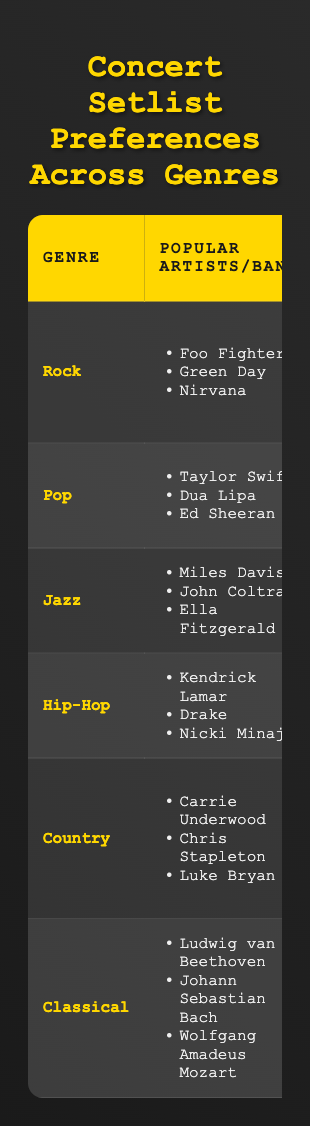What is the average song length for the Pop genre? The table shows that the average song length for the Pop genre is listed as 3:30.
Answer: 3:30 Which genre has the highest audience engagement level? According to the table, both Rock and Hip-Hop have the highest audience engagement level, categorized as "High."
Answer: Rock and Hip-Hop What are the notable instruments used in the Country genre? The table lists "Acoustic Guitar," "Banjo," and "Pedal Steel" as the notable instruments in the Country genre.
Answer: Acoustic Guitar, Banjo, Pedal Steel Which genre features the longest average song length? The average song length for Classical is 7:30, which is longer than Rock (4:15), Pop (3:30), Hip-Hop (3:45), Country (4:20), and Jazz (6:00). Thus, Classical has the longest average song length.
Answer: Classical Is "Symphony No. 5" a popular song title in the Hip-Hop genre? The table states that "Symphony No. 5" is listed under Classical genre, not Hip-Hop. Therefore, it is not a popular song title in Hip-Hop.
Answer: No How many different music genres have a "medium" engagement level? From the table, the genres with a "medium" audience engagement level are Pop and Country, which totals to two genres.
Answer: 2 In which genre is the average song length shorter than 4 minutes? The Pop genre has an average song length of 3:30, which is shorter than 4 minutes. Similarly, the Hip-Hop genre at 3:45 is also shorter than 4 minutes.
Answer: Pop and Hip-Hop Which genre has the most notable instruments listed? Each genre lists three notable instruments. Therefore, there is no genre with more notable instruments than the others; they are all equal in this regard.
Answer: None (equal) What is the average song length difference between Rock and Jazz? The average length of Rock is 4:15 and Jazz is 6:00. First, convert these times into minutes: Rock: 4.25 minutes, Jazz: 6.00 minutes. The difference is 6.00 - 4.25 = 1.75 minutes, or 1 minute and 45 seconds.
Answer: 1:45 Which popular artist is associated with the Jazz genre? The table lists "Miles Davis," "John Coltrane," and "Ella Fitzgerald" as popular artists in the Jazz genre.
Answer: Miles Davis, John Coltrane, Ella Fitzgerald 